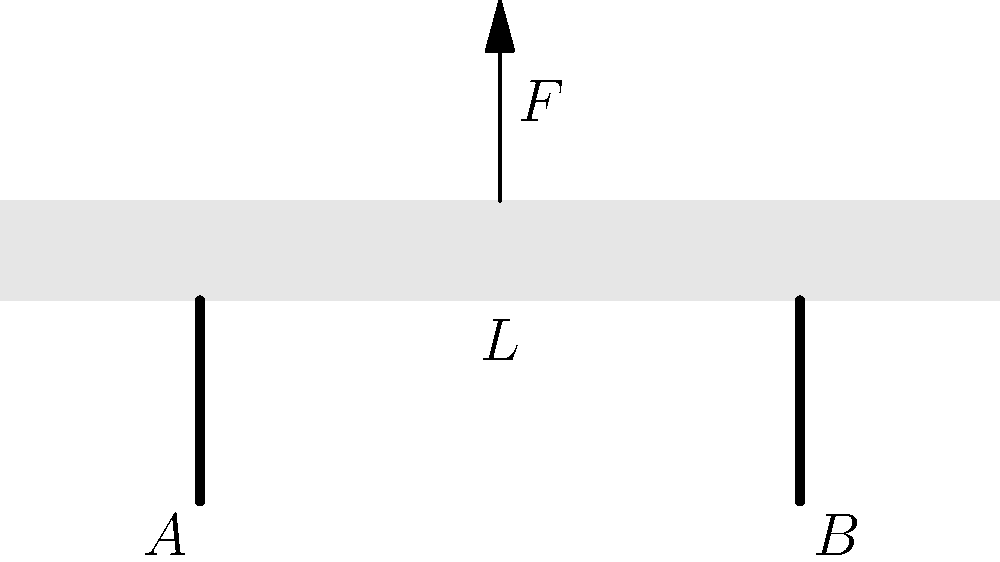During One Direction's stadium tour, a concentrated load $F$ is applied at the center of the stage, which is supported by two beams at points A and B. The stage has a length $L$ of 10 meters. If the maximum allowable reaction force at each support is 15 kN, what is the maximum concentrated load $F$ that can be safely applied to the center of the stage? Let's approach this step-by-step:

1) First, we need to understand that this is a statically determinate beam problem with a concentrated load at the center.

2) The reaction forces at supports A and B will be equal due to symmetry. Let's call each reaction force $R$.

3) For equilibrium, the sum of forces must be zero:
   $$F = R_A + R_B = 2R$$

4) Taking moments about point A:
   $$F \cdot \frac{L}{2} = R_B \cdot L$$
   $$F \cdot 5 = R \cdot 10$$
   $$F = 2R$$

5) We're told that the maximum allowable reaction force at each support is 15 kN. So:
   $$R_{max} = 15 \text{ kN}$$

6) Using the relationship we found in step 4:
   $$F_{max} = 2R_{max} = 2 \cdot 15 \text{ kN} = 30 \text{ kN}$$

Therefore, the maximum concentrated load that can be safely applied at the center of the stage is 30 kN.
Answer: 30 kN 